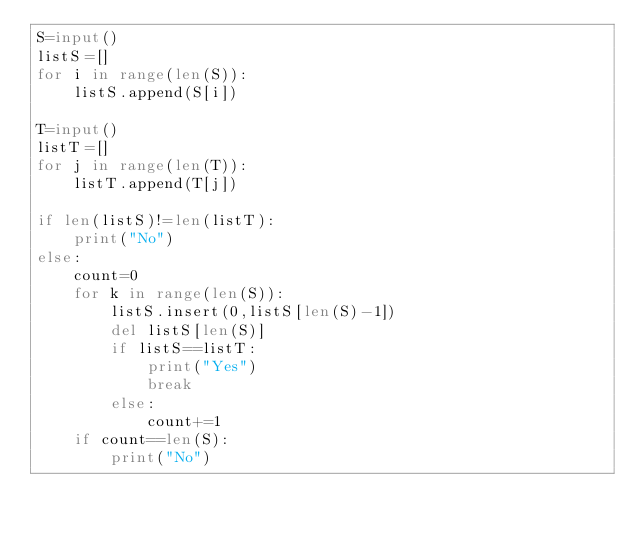<code> <loc_0><loc_0><loc_500><loc_500><_Python_>S=input()
listS=[]
for i in range(len(S)):
    listS.append(S[i])

T=input()
listT=[]
for j in range(len(T)):
    listT.append(T[j])

if len(listS)!=len(listT):
    print("No")
else:
    count=0
    for k in range(len(S)):
        listS.insert(0,listS[len(S)-1])
        del listS[len(S)]
        if listS==listT:
            print("Yes")
            break
        else:
            count+=1
    if count==len(S):        
        print("No")</code> 